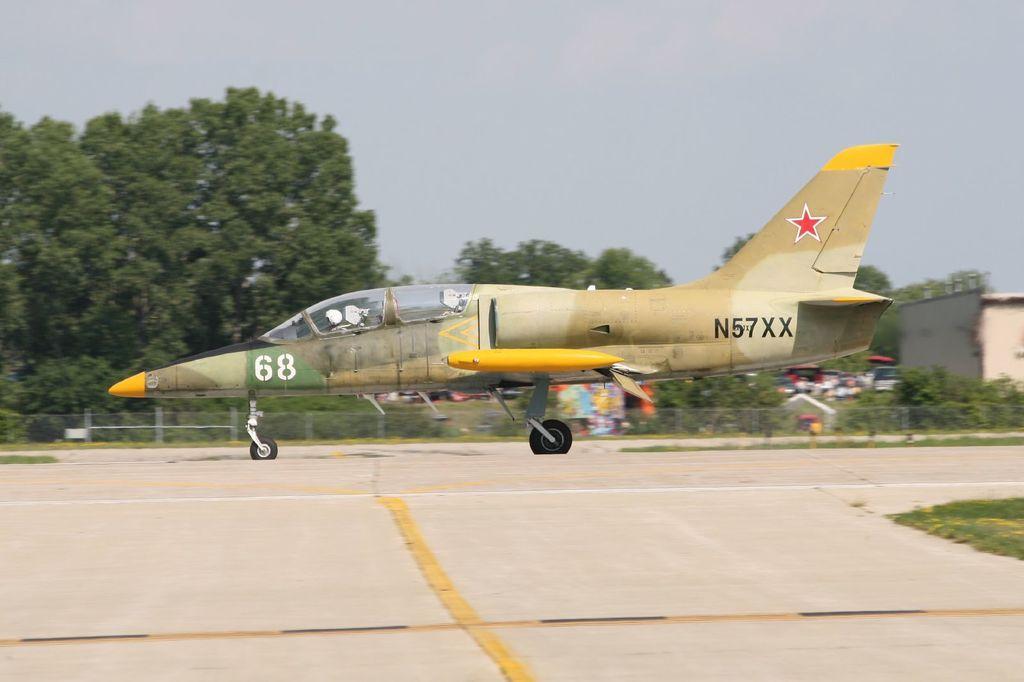Please provide a concise description of this image. In the image we can see a flying jet, in it there is a person sitting. There is a road, grass, vehicles, fence, trees and a sky. 